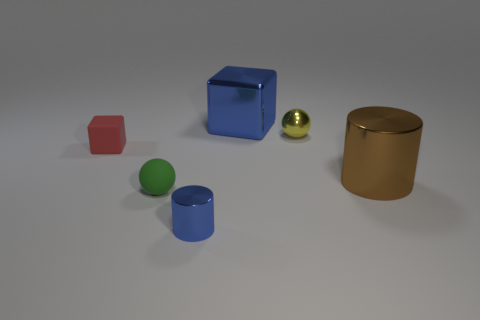Add 2 large cyan metallic balls. How many objects exist? 8 Add 4 big shiny objects. How many big shiny objects are left? 6 Add 4 small green balls. How many small green balls exist? 5 Subtract 0 purple balls. How many objects are left? 6 Subtract all blue cylinders. Subtract all small green balls. How many objects are left? 4 